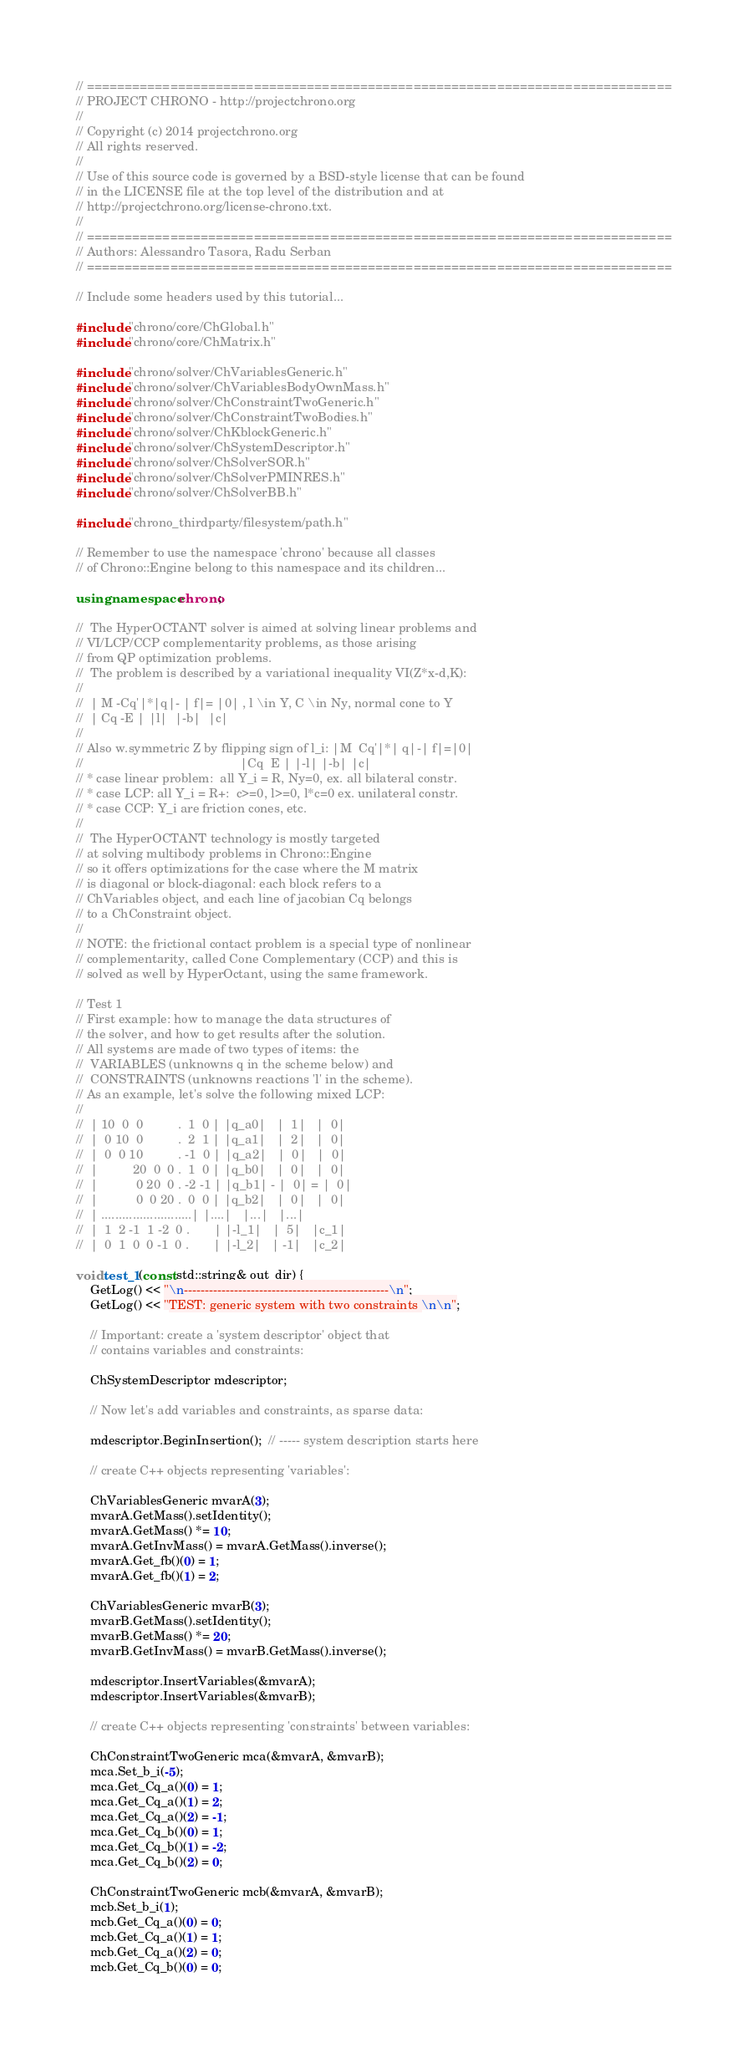Convert code to text. <code><loc_0><loc_0><loc_500><loc_500><_C++_>// =============================================================================
// PROJECT CHRONO - http://projectchrono.org
//
// Copyright (c) 2014 projectchrono.org
// All rights reserved.
//
// Use of this source code is governed by a BSD-style license that can be found
// in the LICENSE file at the top level of the distribution and at
// http://projectchrono.org/license-chrono.txt.
//
// =============================================================================
// Authors: Alessandro Tasora, Radu Serban
// =============================================================================

// Include some headers used by this tutorial...

#include "chrono/core/ChGlobal.h"
#include "chrono/core/ChMatrix.h"

#include "chrono/solver/ChVariablesGeneric.h"
#include "chrono/solver/ChVariablesBodyOwnMass.h"
#include "chrono/solver/ChConstraintTwoGeneric.h"
#include "chrono/solver/ChConstraintTwoBodies.h"
#include "chrono/solver/ChKblockGeneric.h"
#include "chrono/solver/ChSystemDescriptor.h"
#include "chrono/solver/ChSolverSOR.h"
#include "chrono/solver/ChSolverPMINRES.h"
#include "chrono/solver/ChSolverBB.h"

#include "chrono_thirdparty/filesystem/path.h"

// Remember to use the namespace 'chrono' because all classes
// of Chrono::Engine belong to this namespace and its children...

using namespace chrono;

//  The HyperOCTANT solver is aimed at solving linear problems and
// VI/LCP/CCP complementarity problems, as those arising
// from QP optimization problems.
//  The problem is described by a variational inequality VI(Z*x-d,K):
//
//  | M -Cq'|*|q|- | f|= |0| , l \in Y, C \in Ny, normal cone to Y
//  | Cq -E | |l|  |-b|  |c|
//
// Also w.symmetric Z by flipping sign of l_i: |M  Cq'|*| q|-| f|=|0|
//                                             |Cq  E | |-l| |-b| |c|
// * case linear problem:  all Y_i = R, Ny=0, ex. all bilateral constr.
// * case LCP: all Y_i = R+:  c>=0, l>=0, l*c=0 ex. unilateral constr.
// * case CCP: Y_i are friction cones, etc.
//
//  The HyperOCTANT technology is mostly targeted
// at solving multibody problems in Chrono::Engine
// so it offers optimizations for the case where the M matrix
// is diagonal or block-diagonal: each block refers to a
// ChVariables object, and each line of jacobian Cq belongs
// to a ChConstraint object.
//
// NOTE: the frictional contact problem is a special type of nonlinear
// complementarity, called Cone Complementary (CCP) and this is
// solved as well by HyperOctant, using the same framework.

// Test 1
// First example: how to manage the data structures of
// the solver, and how to get results after the solution.
// All systems are made of two types of items: the
//  VARIABLES (unknowns q in the scheme below) and
//  CONSTRAINTS (unknowns reactions 'l' in the scheme).
// As an example, let's solve the following mixed LCP:
//
//  | 10  0  0          .  1  0 | |q_a0|   |  1|   |  0|
//  |  0 10  0          .  2  1 | |q_a1|   |  2|   |  0|
//  |  0  0 10          . -1  0 | |q_a2|   |  0|   |  0|
//  |          20  0  0 .  1  0 | |q_b0|   |  0|   |  0|
//  |           0 20  0 . -2 -1 | |q_b1| - |  0| = |  0|
//  |           0  0 20 .  0  0 | |q_b2|   |  0|   |  0|
//  | ..........................| |....|   |...|   |...|
//  |  1  2 -1  1 -2  0 .       | |-l_1|   |  5|   |c_1|
//  |  0  1  0  0 -1  0 .       | |-l_2|   | -1|   |c_2|

void test_1(const std::string& out_dir) {
    GetLog() << "\n-------------------------------------------------\n";
    GetLog() << "TEST: generic system with two constraints \n\n";

    // Important: create a 'system descriptor' object that
    // contains variables and constraints:

    ChSystemDescriptor mdescriptor;

    // Now let's add variables and constraints, as sparse data:

    mdescriptor.BeginInsertion();  // ----- system description starts here

    // create C++ objects representing 'variables':

    ChVariablesGeneric mvarA(3);
    mvarA.GetMass().setIdentity();
    mvarA.GetMass() *= 10;
    mvarA.GetInvMass() = mvarA.GetMass().inverse();
    mvarA.Get_fb()(0) = 1;
    mvarA.Get_fb()(1) = 2;

    ChVariablesGeneric mvarB(3);
    mvarB.GetMass().setIdentity();
    mvarB.GetMass() *= 20;
    mvarB.GetInvMass() = mvarB.GetMass().inverse();

    mdescriptor.InsertVariables(&mvarA);
    mdescriptor.InsertVariables(&mvarB);

    // create C++ objects representing 'constraints' between variables:

    ChConstraintTwoGeneric mca(&mvarA, &mvarB);
    mca.Set_b_i(-5);
    mca.Get_Cq_a()(0) = 1;
    mca.Get_Cq_a()(1) = 2;
    mca.Get_Cq_a()(2) = -1;
    mca.Get_Cq_b()(0) = 1;
    mca.Get_Cq_b()(1) = -2;
    mca.Get_Cq_b()(2) = 0;

    ChConstraintTwoGeneric mcb(&mvarA, &mvarB);
    mcb.Set_b_i(1);
    mcb.Get_Cq_a()(0) = 0;
    mcb.Get_Cq_a()(1) = 1;
    mcb.Get_Cq_a()(2) = 0;
    mcb.Get_Cq_b()(0) = 0;</code> 